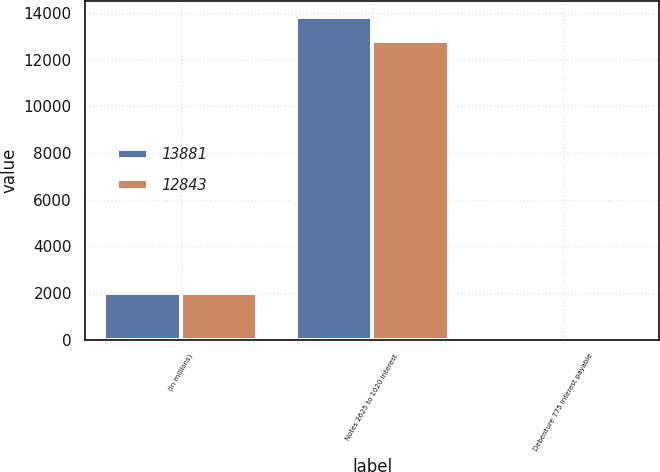<chart> <loc_0><loc_0><loc_500><loc_500><stacked_bar_chart><ecel><fcel>(in millions)<fcel>Notes 2625 to 1020 interest<fcel>Debenture 775 interest payable<nl><fcel>13881<fcel>2016<fcel>13839<fcel>42<nl><fcel>12843<fcel>2015<fcel>12789<fcel>42<nl></chart> 